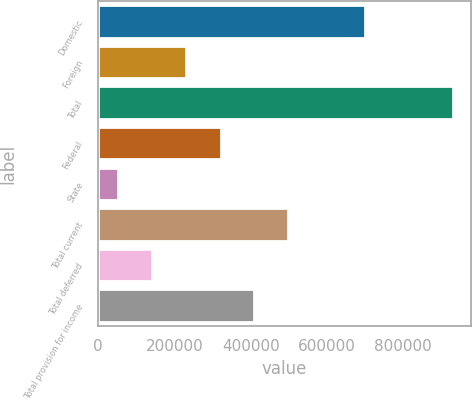Convert chart to OTSL. <chart><loc_0><loc_0><loc_500><loc_500><bar_chart><fcel>Domestic<fcel>Foreign<fcel>Total<fcel>Federal<fcel>State<fcel>Total current<fcel>Total deferred<fcel>Total provision for income<nl><fcel>700157<fcel>231519<fcel>931676<fcel>322244<fcel>53178<fcel>497944<fcel>141028<fcel>410094<nl></chart> 